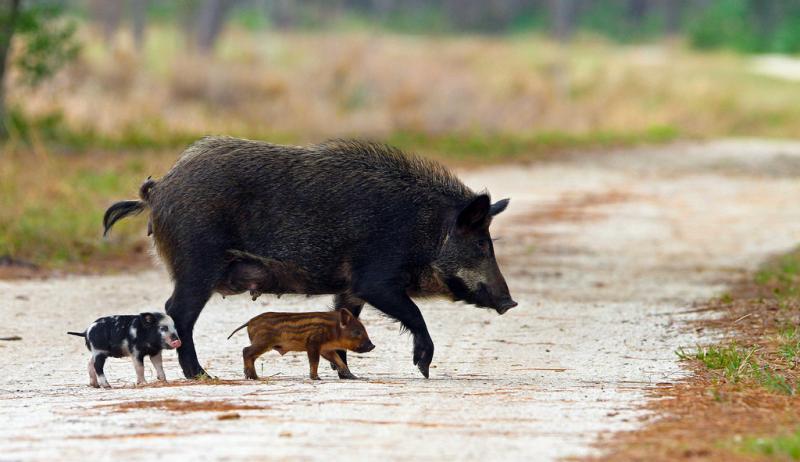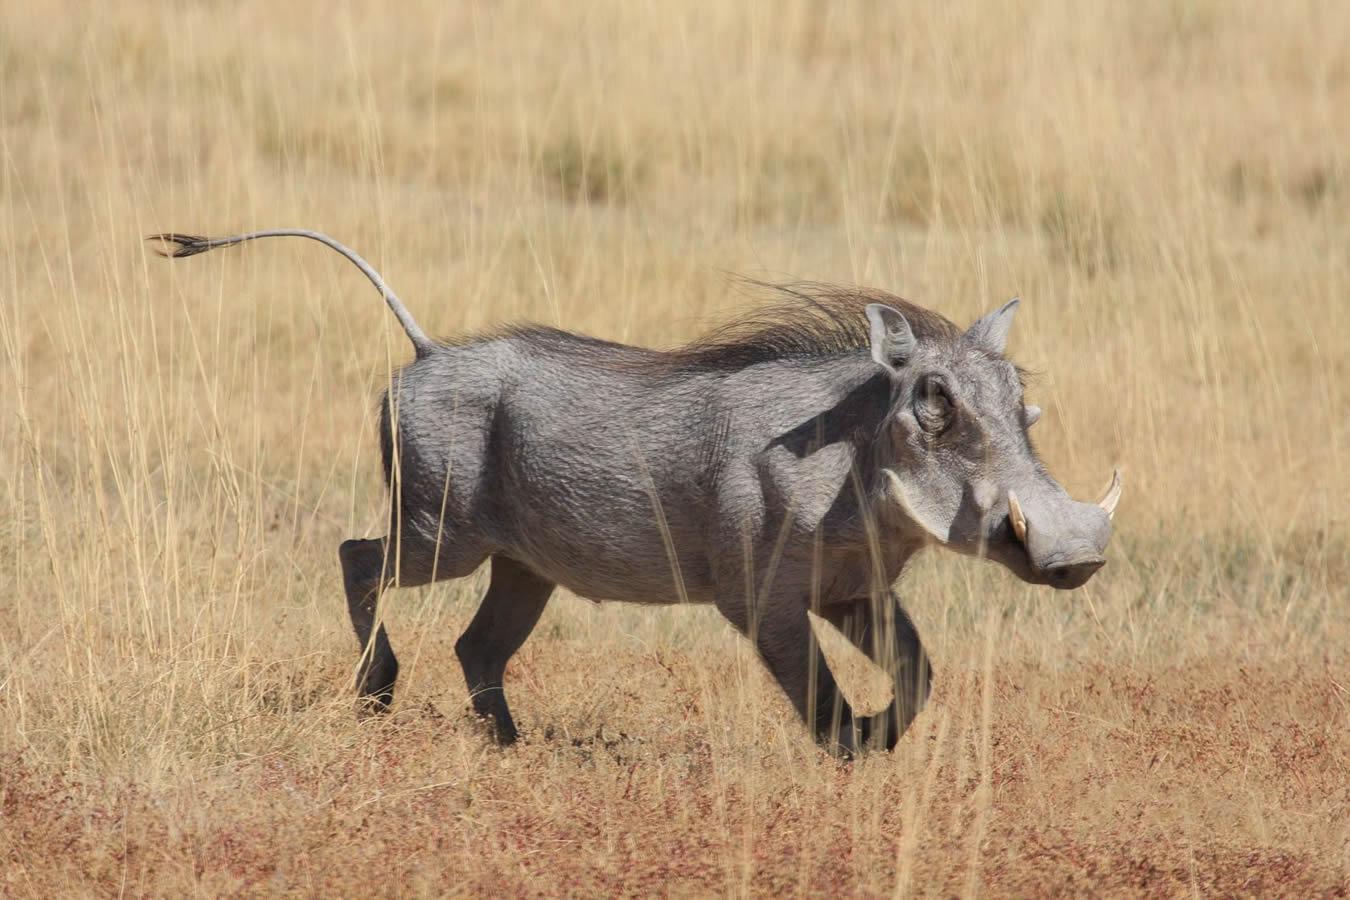The first image is the image on the left, the second image is the image on the right. Assess this claim about the two images: "There are more than two animals total.". Correct or not? Answer yes or no. Yes. 